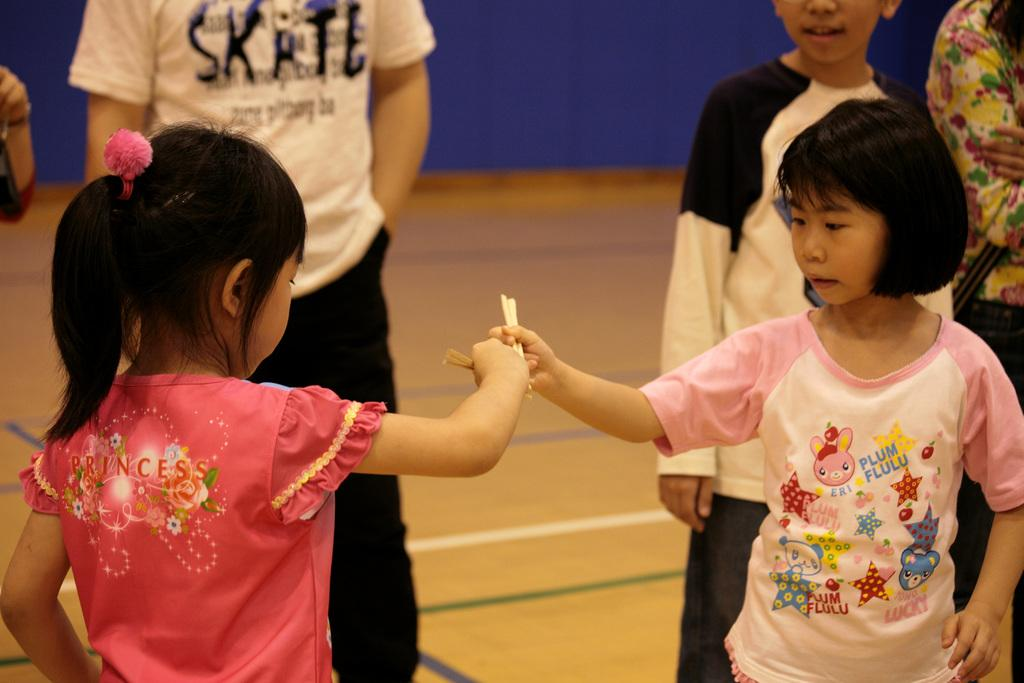Who can be seen in the image? There are children visible in the image. What can be seen in the background of the image? There is a blue color fence visible in the background of the image. What is the condition of the arm of the train in the image? There is no train present in the image, so it is not possible to determine the condition of its arm. 